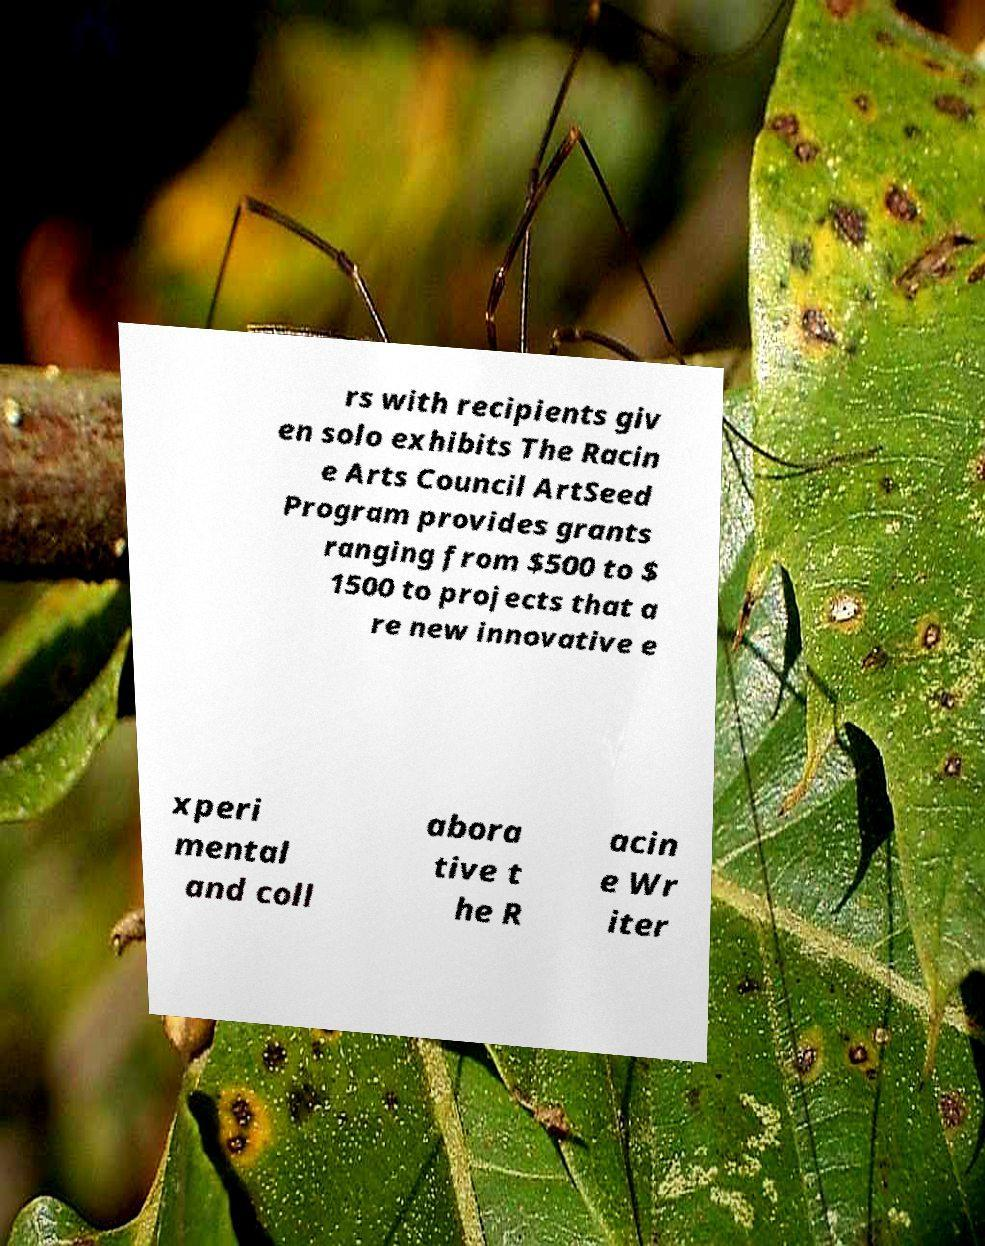Could you assist in decoding the text presented in this image and type it out clearly? rs with recipients giv en solo exhibits The Racin e Arts Council ArtSeed Program provides grants ranging from $500 to $ 1500 to projects that a re new innovative e xperi mental and coll abora tive t he R acin e Wr iter 